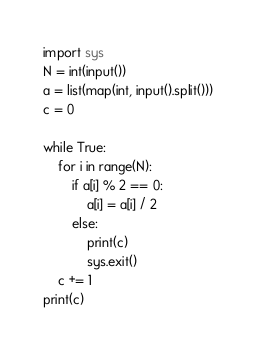<code> <loc_0><loc_0><loc_500><loc_500><_Python_>import sys
N = int(input())
a = list(map(int, input().split()))
c = 0

while True:
    for i in range(N):
        if a[i] % 2 == 0:
            a[i] = a[i] / 2
        else:
            print(c)
            sys.exit()
    c += 1
print(c)</code> 